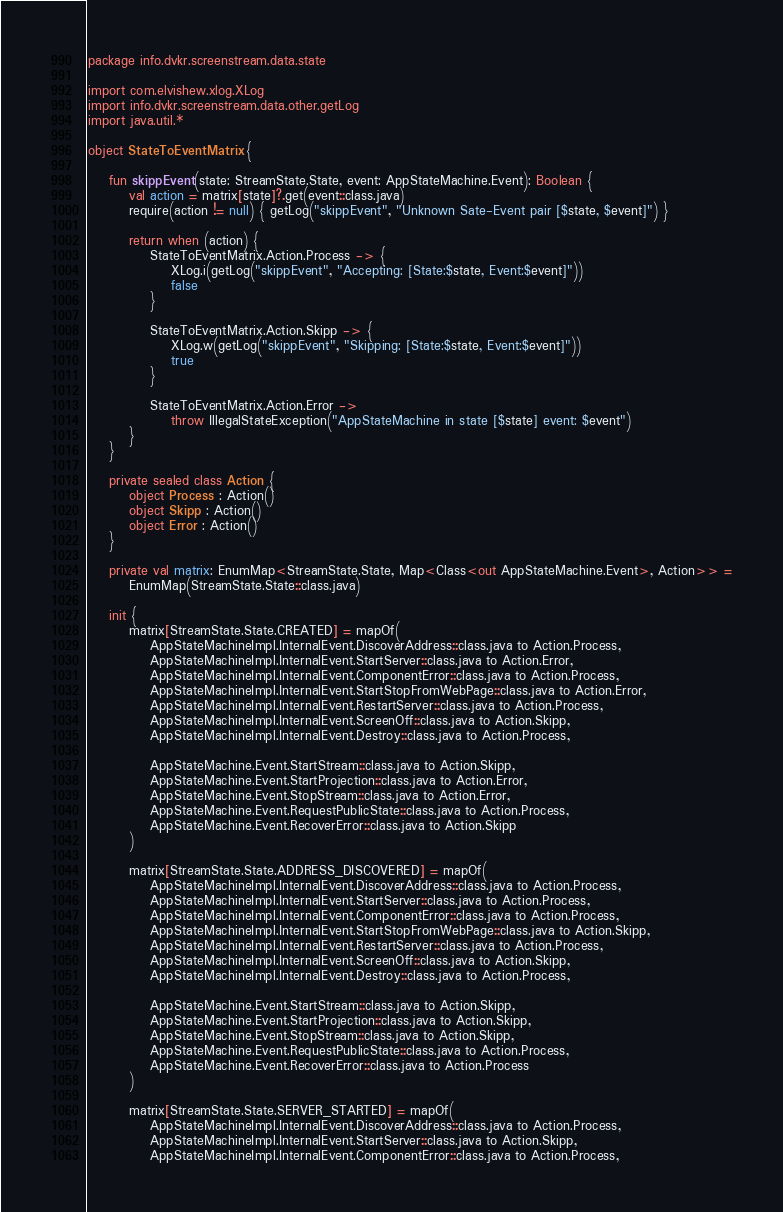Convert code to text. <code><loc_0><loc_0><loc_500><loc_500><_Kotlin_>package info.dvkr.screenstream.data.state

import com.elvishew.xlog.XLog
import info.dvkr.screenstream.data.other.getLog
import java.util.*

object StateToEventMatrix {

    fun skippEvent(state: StreamState.State, event: AppStateMachine.Event): Boolean {
        val action = matrix[state]?.get(event::class.java)
        require(action != null) { getLog("skippEvent", "Unknown Sate-Event pair [$state, $event]") }

        return when (action) {
            StateToEventMatrix.Action.Process -> {
                XLog.i(getLog("skippEvent", "Accepting: [State:$state, Event:$event]"))
                false
            }

            StateToEventMatrix.Action.Skipp -> {
                XLog.w(getLog("skippEvent", "Skipping: [State:$state, Event:$event]"))
                true
            }

            StateToEventMatrix.Action.Error ->
                throw IllegalStateException("AppStateMachine in state [$state] event: $event")
        }
    }

    private sealed class Action {
        object Process : Action()
        object Skipp : Action()
        object Error : Action()
    }

    private val matrix: EnumMap<StreamState.State, Map<Class<out AppStateMachine.Event>, Action>> =
        EnumMap(StreamState.State::class.java)

    init {
        matrix[StreamState.State.CREATED] = mapOf(
            AppStateMachineImpl.InternalEvent.DiscoverAddress::class.java to Action.Process,
            AppStateMachineImpl.InternalEvent.StartServer::class.java to Action.Error,
            AppStateMachineImpl.InternalEvent.ComponentError::class.java to Action.Process,
            AppStateMachineImpl.InternalEvent.StartStopFromWebPage::class.java to Action.Error,
            AppStateMachineImpl.InternalEvent.RestartServer::class.java to Action.Process,
            AppStateMachineImpl.InternalEvent.ScreenOff::class.java to Action.Skipp,
            AppStateMachineImpl.InternalEvent.Destroy::class.java to Action.Process,

            AppStateMachine.Event.StartStream::class.java to Action.Skipp,
            AppStateMachine.Event.StartProjection::class.java to Action.Error,
            AppStateMachine.Event.StopStream::class.java to Action.Error,
            AppStateMachine.Event.RequestPublicState::class.java to Action.Process,
            AppStateMachine.Event.RecoverError::class.java to Action.Skipp
        )

        matrix[StreamState.State.ADDRESS_DISCOVERED] = mapOf(
            AppStateMachineImpl.InternalEvent.DiscoverAddress::class.java to Action.Process,
            AppStateMachineImpl.InternalEvent.StartServer::class.java to Action.Process,
            AppStateMachineImpl.InternalEvent.ComponentError::class.java to Action.Process,
            AppStateMachineImpl.InternalEvent.StartStopFromWebPage::class.java to Action.Skipp,
            AppStateMachineImpl.InternalEvent.RestartServer::class.java to Action.Process,
            AppStateMachineImpl.InternalEvent.ScreenOff::class.java to Action.Skipp,
            AppStateMachineImpl.InternalEvent.Destroy::class.java to Action.Process,

            AppStateMachine.Event.StartStream::class.java to Action.Skipp,
            AppStateMachine.Event.StartProjection::class.java to Action.Skipp,
            AppStateMachine.Event.StopStream::class.java to Action.Skipp,
            AppStateMachine.Event.RequestPublicState::class.java to Action.Process,
            AppStateMachine.Event.RecoverError::class.java to Action.Process
        )

        matrix[StreamState.State.SERVER_STARTED] = mapOf(
            AppStateMachineImpl.InternalEvent.DiscoverAddress::class.java to Action.Process,
            AppStateMachineImpl.InternalEvent.StartServer::class.java to Action.Skipp,
            AppStateMachineImpl.InternalEvent.ComponentError::class.java to Action.Process,</code> 